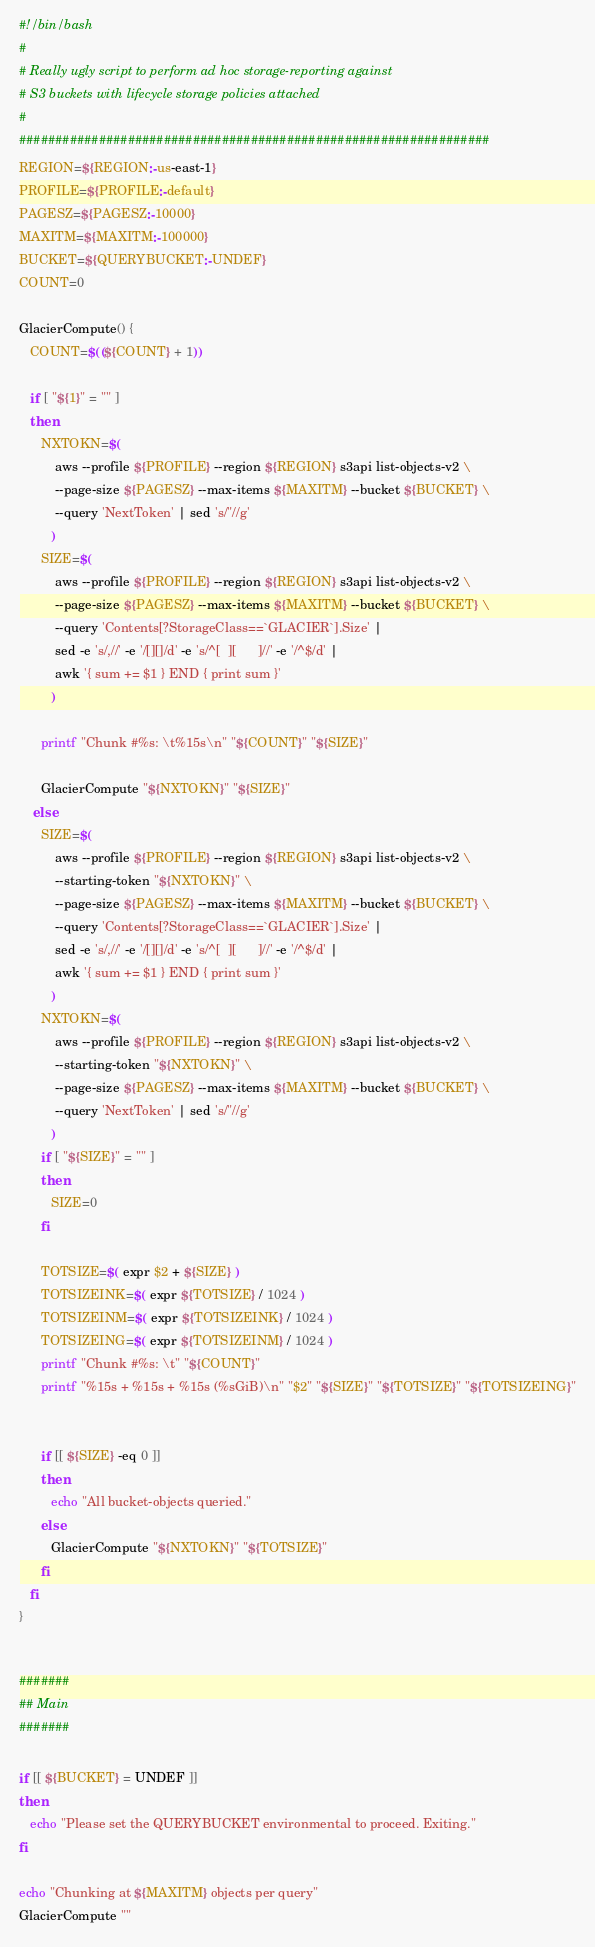<code> <loc_0><loc_0><loc_500><loc_500><_Bash_>#!/bin/bash
#
# Really ugly script to perform ad hoc storage-reporting against
# S3 buckets with lifecycle storage policies attached
#
#################################################################
REGION=${REGION:-us-east-1}
PROFILE=${PROFILE:-default}
PAGESZ=${PAGESZ:-10000}
MAXITM=${MAXITM:-100000}
BUCKET=${QUERYBUCKET:-UNDEF}
COUNT=0

GlacierCompute() {
   COUNT=$((${COUNT} + 1))

   if [ "${1}" = "" ]
   then
      NXTOKN=$(
          aws --profile ${PROFILE} --region ${REGION} s3api list-objects-v2 \
          --page-size ${PAGESZ} --max-items ${MAXITM} --bucket ${BUCKET} \
          --query 'NextToken' | sed 's/"//g'
         )
      SIZE=$(
          aws --profile ${PROFILE} --region ${REGION} s3api list-objects-v2 \
          --page-size ${PAGESZ} --max-items ${MAXITM} --bucket ${BUCKET} \
          --query 'Contents[?StorageClass==`GLACIER`].Size' |
          sed -e 's/,//' -e '/[][]/d' -e 's/^[  ][      ]//' -e '/^$/d' |
          awk '{ sum += $1 } END { print sum }'
         )

      printf "Chunk #%s: \t%15s\n" "${COUNT}" "${SIZE}"

      GlacierCompute "${NXTOKN}" "${SIZE}"
    else
      SIZE=$(
          aws --profile ${PROFILE} --region ${REGION} s3api list-objects-v2 \
          --starting-token "${NXTOKN}" \
          --page-size ${PAGESZ} --max-items ${MAXITM} --bucket ${BUCKET} \
          --query 'Contents[?StorageClass==`GLACIER`].Size' |
          sed -e 's/,//' -e '/[][]/d' -e 's/^[  ][      ]//' -e '/^$/d' |
          awk '{ sum += $1 } END { print sum }'
         )
      NXTOKN=$(
          aws --profile ${PROFILE} --region ${REGION} s3api list-objects-v2 \
          --starting-token "${NXTOKN}" \
          --page-size ${PAGESZ} --max-items ${MAXITM} --bucket ${BUCKET} \
          --query 'NextToken' | sed 's/"//g'
         )
      if [ "${SIZE}" = "" ]
      then
         SIZE=0
      fi

      TOTSIZE=$( expr $2 + ${SIZE} )
      TOTSIZEINK=$( expr ${TOTSIZE} / 1024 )
      TOTSIZEINM=$( expr ${TOTSIZEINK} / 1024 )
      TOTSIZEING=$( expr ${TOTSIZEINM} / 1024 )
      printf "Chunk #%s: \t" "${COUNT}"
      printf "%15s + %15s + %15s (%sGiB)\n" "$2" "${SIZE}" "${TOTSIZE}" "${TOTSIZEING}"


      if [[ ${SIZE} -eq 0 ]]
      then
         echo "All bucket-objects queried."
      else
         GlacierCompute "${NXTOKN}" "${TOTSIZE}"
      fi
   fi
}


#######
## Main
#######

if [[ ${BUCKET} = UNDEF ]]
then
   echo "Please set the QUERYBUCKET environmental to proceed. Exiting."
fi

echo "Chunking at ${MAXITM} objects per query"
GlacierCompute ""
</code> 